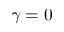Convert formula to latex. <formula><loc_0><loc_0><loc_500><loc_500>\gamma = 0</formula> 